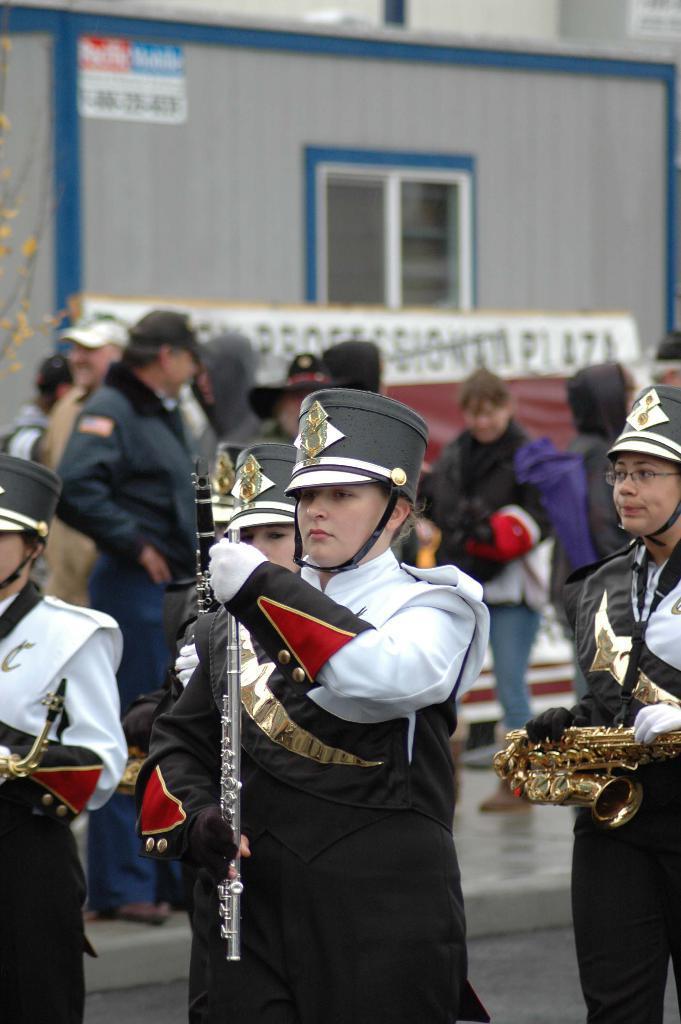Could you give a brief overview of what you see in this image? In this image in the foreground there are some people who are holding musical instruments and wearing hats. And in the background there are a group of people and building, window and some boards, at the bottom there is walkway. 